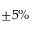<formula> <loc_0><loc_0><loc_500><loc_500>\pm 5 \%</formula> 